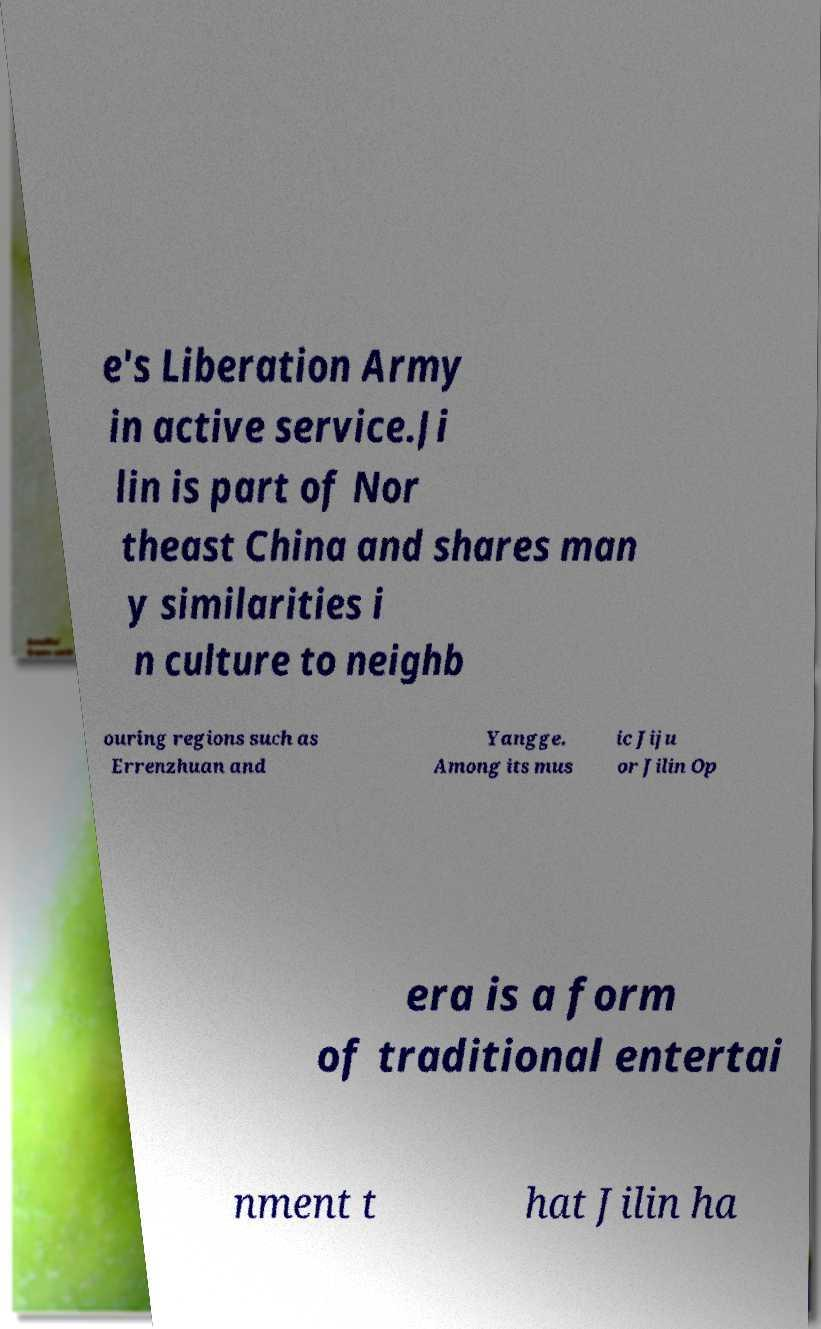For documentation purposes, I need the text within this image transcribed. Could you provide that? e's Liberation Army in active service.Ji lin is part of Nor theast China and shares man y similarities i n culture to neighb ouring regions such as Errenzhuan and Yangge. Among its mus ic Jiju or Jilin Op era is a form of traditional entertai nment t hat Jilin ha 